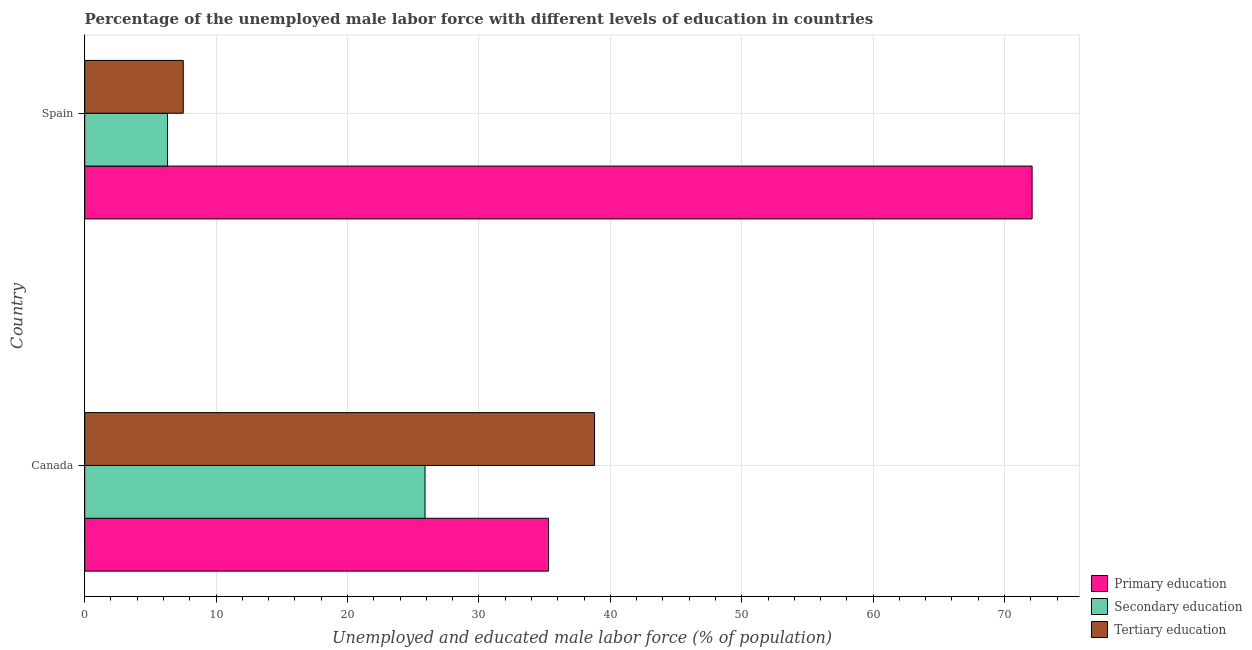How many groups of bars are there?
Ensure brevity in your answer.  2. Are the number of bars on each tick of the Y-axis equal?
Offer a terse response. Yes. How many bars are there on the 2nd tick from the bottom?
Offer a terse response. 3. In how many cases, is the number of bars for a given country not equal to the number of legend labels?
Your response must be concise. 0. What is the percentage of male labor force who received secondary education in Canada?
Provide a short and direct response. 25.9. Across all countries, what is the maximum percentage of male labor force who received tertiary education?
Keep it short and to the point. 38.8. Across all countries, what is the minimum percentage of male labor force who received tertiary education?
Your response must be concise. 7.5. In which country was the percentage of male labor force who received secondary education maximum?
Your response must be concise. Canada. What is the total percentage of male labor force who received primary education in the graph?
Make the answer very short. 107.4. What is the difference between the percentage of male labor force who received tertiary education in Canada and that in Spain?
Provide a succinct answer. 31.3. What is the difference between the percentage of male labor force who received primary education in Canada and the percentage of male labor force who received tertiary education in Spain?
Offer a terse response. 27.8. What is the average percentage of male labor force who received tertiary education per country?
Offer a very short reply. 23.15. What is the difference between the percentage of male labor force who received tertiary education and percentage of male labor force who received secondary education in Spain?
Provide a short and direct response. 1.2. In how many countries, is the percentage of male labor force who received tertiary education greater than 58 %?
Offer a terse response. 0. What is the ratio of the percentage of male labor force who received tertiary education in Canada to that in Spain?
Your answer should be very brief. 5.17. Is the percentage of male labor force who received tertiary education in Canada less than that in Spain?
Your response must be concise. No. In how many countries, is the percentage of male labor force who received tertiary education greater than the average percentage of male labor force who received tertiary education taken over all countries?
Provide a succinct answer. 1. What does the 2nd bar from the top in Canada represents?
Make the answer very short. Secondary education. What does the 1st bar from the bottom in Spain represents?
Ensure brevity in your answer.  Primary education. Is it the case that in every country, the sum of the percentage of male labor force who received primary education and percentage of male labor force who received secondary education is greater than the percentage of male labor force who received tertiary education?
Your answer should be compact. Yes. How many bars are there?
Provide a succinct answer. 6. Are all the bars in the graph horizontal?
Offer a terse response. Yes. How many countries are there in the graph?
Provide a succinct answer. 2. Are the values on the major ticks of X-axis written in scientific E-notation?
Offer a terse response. No. How many legend labels are there?
Keep it short and to the point. 3. How are the legend labels stacked?
Offer a terse response. Vertical. What is the title of the graph?
Make the answer very short. Percentage of the unemployed male labor force with different levels of education in countries. What is the label or title of the X-axis?
Your answer should be compact. Unemployed and educated male labor force (% of population). What is the label or title of the Y-axis?
Your response must be concise. Country. What is the Unemployed and educated male labor force (% of population) in Primary education in Canada?
Your response must be concise. 35.3. What is the Unemployed and educated male labor force (% of population) of Secondary education in Canada?
Your response must be concise. 25.9. What is the Unemployed and educated male labor force (% of population) in Tertiary education in Canada?
Keep it short and to the point. 38.8. What is the Unemployed and educated male labor force (% of population) in Primary education in Spain?
Ensure brevity in your answer.  72.1. What is the Unemployed and educated male labor force (% of population) of Secondary education in Spain?
Ensure brevity in your answer.  6.3. Across all countries, what is the maximum Unemployed and educated male labor force (% of population) in Primary education?
Provide a succinct answer. 72.1. Across all countries, what is the maximum Unemployed and educated male labor force (% of population) in Secondary education?
Provide a succinct answer. 25.9. Across all countries, what is the maximum Unemployed and educated male labor force (% of population) of Tertiary education?
Ensure brevity in your answer.  38.8. Across all countries, what is the minimum Unemployed and educated male labor force (% of population) of Primary education?
Give a very brief answer. 35.3. Across all countries, what is the minimum Unemployed and educated male labor force (% of population) of Secondary education?
Your response must be concise. 6.3. Across all countries, what is the minimum Unemployed and educated male labor force (% of population) in Tertiary education?
Keep it short and to the point. 7.5. What is the total Unemployed and educated male labor force (% of population) of Primary education in the graph?
Give a very brief answer. 107.4. What is the total Unemployed and educated male labor force (% of population) of Secondary education in the graph?
Offer a very short reply. 32.2. What is the total Unemployed and educated male labor force (% of population) of Tertiary education in the graph?
Give a very brief answer. 46.3. What is the difference between the Unemployed and educated male labor force (% of population) in Primary education in Canada and that in Spain?
Keep it short and to the point. -36.8. What is the difference between the Unemployed and educated male labor force (% of population) of Secondary education in Canada and that in Spain?
Your response must be concise. 19.6. What is the difference between the Unemployed and educated male labor force (% of population) in Tertiary education in Canada and that in Spain?
Give a very brief answer. 31.3. What is the difference between the Unemployed and educated male labor force (% of population) in Primary education in Canada and the Unemployed and educated male labor force (% of population) in Secondary education in Spain?
Your answer should be compact. 29. What is the difference between the Unemployed and educated male labor force (% of population) in Primary education in Canada and the Unemployed and educated male labor force (% of population) in Tertiary education in Spain?
Provide a succinct answer. 27.8. What is the average Unemployed and educated male labor force (% of population) of Primary education per country?
Your answer should be compact. 53.7. What is the average Unemployed and educated male labor force (% of population) in Secondary education per country?
Your response must be concise. 16.1. What is the average Unemployed and educated male labor force (% of population) of Tertiary education per country?
Ensure brevity in your answer.  23.15. What is the difference between the Unemployed and educated male labor force (% of population) in Primary education and Unemployed and educated male labor force (% of population) in Secondary education in Canada?
Offer a terse response. 9.4. What is the difference between the Unemployed and educated male labor force (% of population) in Primary education and Unemployed and educated male labor force (% of population) in Tertiary education in Canada?
Offer a terse response. -3.5. What is the difference between the Unemployed and educated male labor force (% of population) in Primary education and Unemployed and educated male labor force (% of population) in Secondary education in Spain?
Provide a short and direct response. 65.8. What is the difference between the Unemployed and educated male labor force (% of population) of Primary education and Unemployed and educated male labor force (% of population) of Tertiary education in Spain?
Give a very brief answer. 64.6. What is the difference between the Unemployed and educated male labor force (% of population) in Secondary education and Unemployed and educated male labor force (% of population) in Tertiary education in Spain?
Keep it short and to the point. -1.2. What is the ratio of the Unemployed and educated male labor force (% of population) of Primary education in Canada to that in Spain?
Make the answer very short. 0.49. What is the ratio of the Unemployed and educated male labor force (% of population) of Secondary education in Canada to that in Spain?
Offer a very short reply. 4.11. What is the ratio of the Unemployed and educated male labor force (% of population) in Tertiary education in Canada to that in Spain?
Provide a succinct answer. 5.17. What is the difference between the highest and the second highest Unemployed and educated male labor force (% of population) in Primary education?
Provide a succinct answer. 36.8. What is the difference between the highest and the second highest Unemployed and educated male labor force (% of population) of Secondary education?
Your response must be concise. 19.6. What is the difference between the highest and the second highest Unemployed and educated male labor force (% of population) in Tertiary education?
Give a very brief answer. 31.3. What is the difference between the highest and the lowest Unemployed and educated male labor force (% of population) of Primary education?
Keep it short and to the point. 36.8. What is the difference between the highest and the lowest Unemployed and educated male labor force (% of population) of Secondary education?
Your response must be concise. 19.6. What is the difference between the highest and the lowest Unemployed and educated male labor force (% of population) in Tertiary education?
Your response must be concise. 31.3. 